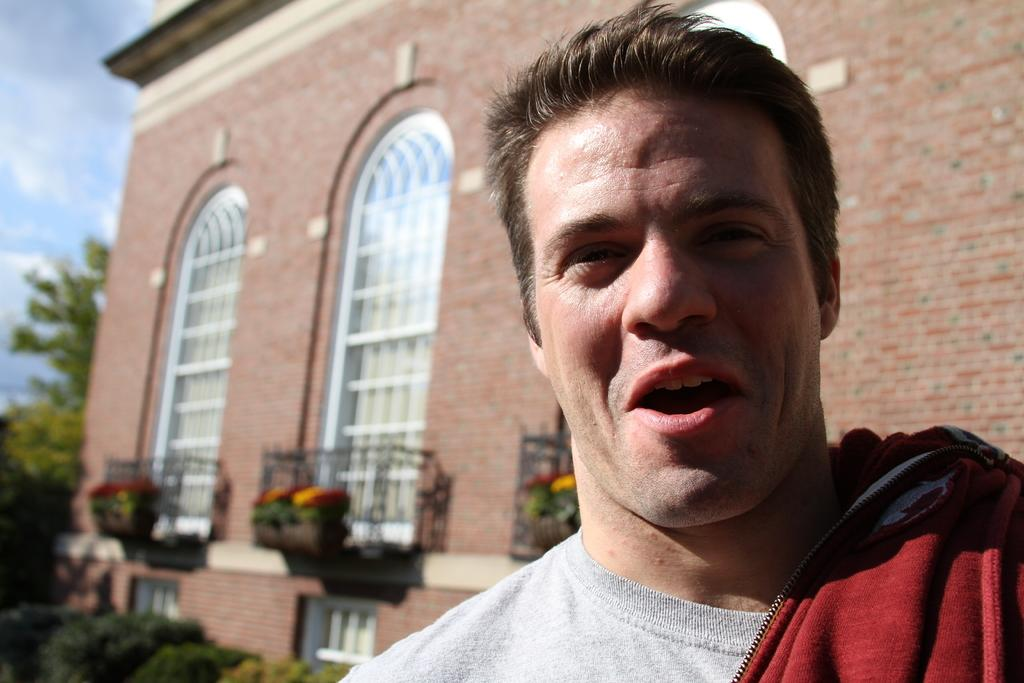Who is the main subject in the image? There is a man in the front of the image. What is the man doing in the image? The man is smiling. What can be seen in the background of the image? There is a building, trees, and plants in the background of the image. What is the weather like in the image? The sky is cloudy in the image. What type of bear can be seen baiting the man in the image? There is no bear present in the image, and therefore no such activity can be observed. What kind of noise is coming from the building in the background? The image does not provide any information about noise coming from the building in the background. 